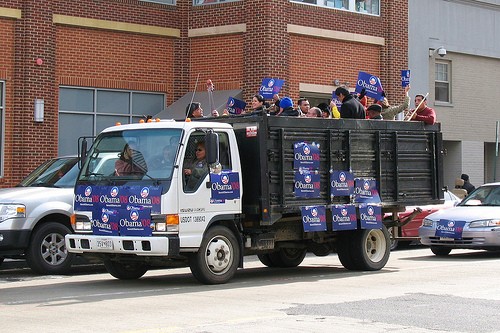Please provide a short description for this region: [0.14, 0.53, 0.33, 0.63]. The front of the truck is covered with Obama '08 signs, except for the windshield. 